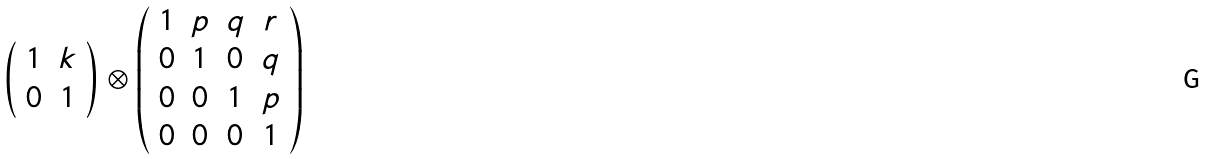<formula> <loc_0><loc_0><loc_500><loc_500>\left ( \begin{array} { c c } { 1 } & { k } \\ { 0 } & { 1 } \end{array} \right ) \otimes \left ( \begin{array} { c c c c } { 1 } & { p } & { q } & { r } \\ { 0 } & { 1 } & { 0 } & { q } \\ { 0 } & { 0 } & { 1 } & { p } \\ { 0 } & { 0 } & { 0 } & { 1 } \end{array} \right )</formula> 